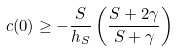Convert formula to latex. <formula><loc_0><loc_0><loc_500><loc_500>c ( 0 ) \geq - \frac { S } { h _ { S } } \left ( \frac { S + 2 \gamma } { S + \gamma } \right )</formula> 